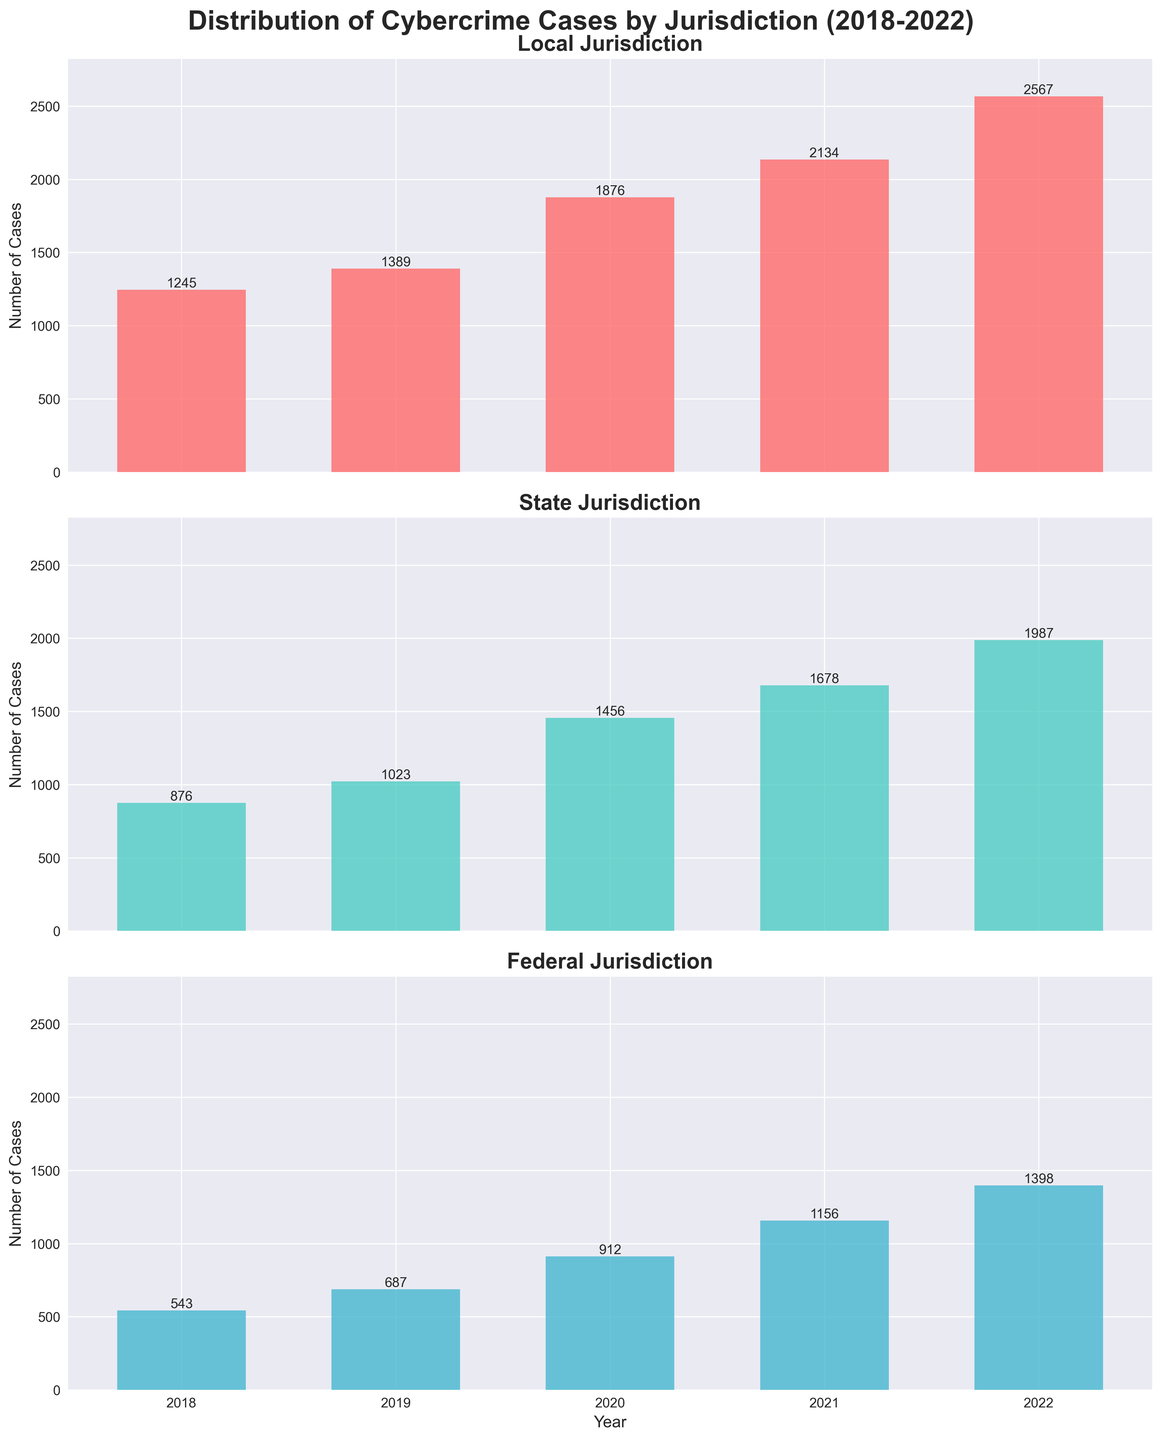What is the total number of cybercrime cases in local jurisdiction in 2021? To find this, look at the bar for the year 2021 in the Local Jurisdiction subplot and read the value.
Answer: 2134 Which jurisdiction had the highest number of cybercrime cases in 2020? Compare the height of the bars for 2020 across all subplots. The Local bar is the highest in 2020.
Answer: Local What is the increase in cybercrime cases in the Federal jurisdiction from 2018 to 2022? Subtract the number of cases in 2018 (543) from the number of cases in 2022 (1398) in the Federal Jurisdiction subplot.
Answer: 855 How does the trend in cybercrime cases in State jurisdiction from 2018 to 2022 compare to the trend in Local jurisdiction over the same period? Both have upward trends, but the Local jurisdiction shows a sharper increase, especially from 2020 onwards, while the State jurisdiction follows a more steady growth.
Answer: Local increased more sharply Which year had the lowest number of cybercrime cases in the State jurisdiction? Check the heights of the bars in the State Jurisdiction subplot and identify the shortest one, which corresponds to 2018.
Answer: 2018 What is the average number of cybercrime cases in the Federal jurisdiction over the last 5 years? Add the values for the years 2018 to 2022 in the Federal Jurisdiction subplot (543 + 687 + 912 + 1156 + 1398) and divide by 5.
Answer: 939.2 Between 2020 and 2021, did the Local jurisdiction see a greater increase in cases than the State jurisdiction? Calculate the increase for both: Local (2134 - 1876 = 258) and State (1678 - 1456 = 222). Local saw a higher increase.
Answer: Yes How many more cases were there in Local jurisdiction than in Federal jurisdiction in 2022? Subtract the Federal cases (1398) from the Local cases (2567) in 2022.
Answer: 1169 What can be inferred about the growth rate of cybercrime cases in Local jurisdiction compared to State and Federal jurisdictions? Local jurisdiction shows a rapid and consistent increase over the years, with the steepest rise among the three jurisdictions, indicating a higher growth rate.
Answer: Highest growth rate in Local Which year showed the smallest difference in the number of cases between State and Federal jurisdictions? Calculate the differences for each year: 2018 (876-543=333), 2019 (1023-687=336), 2020 (1456-912=544), 2021 (1678-1156=522), 2022 (1987-1398=589). 2018 shows the smallest difference.
Answer: 2018 